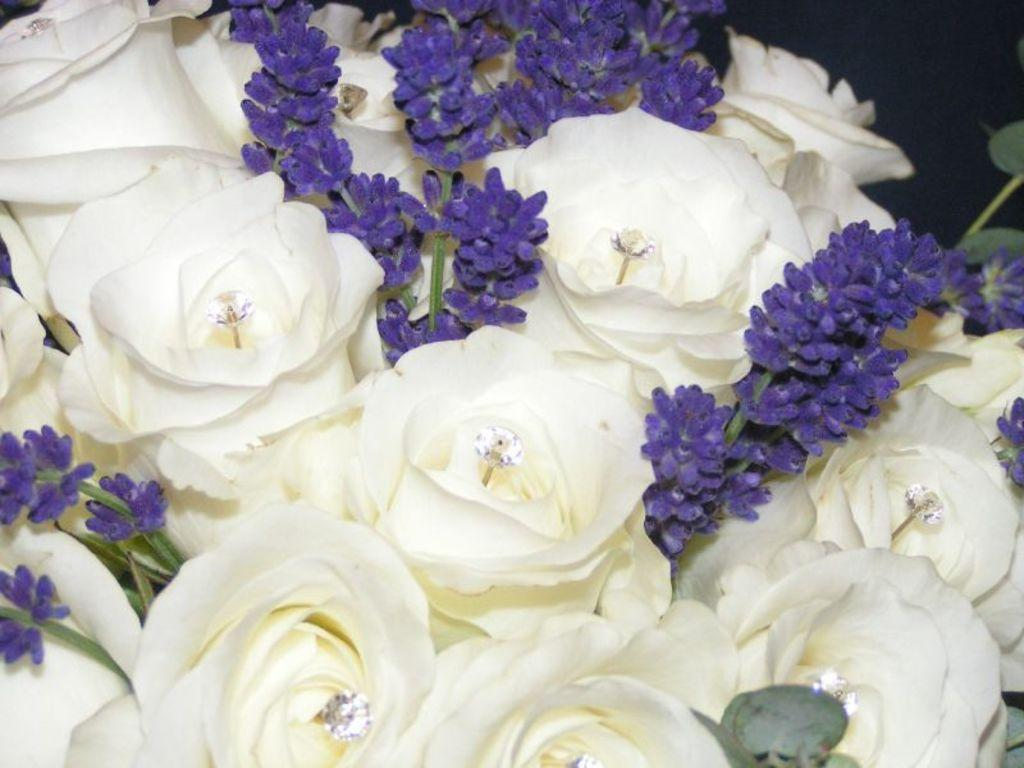What is the main subject of the image? The main subject of the image is flowers. Can you describe the flowers in the image? The flowers are located in the center of the image. What type of amusement can be seen in the image? There is no amusement present in the image; it features flowers in the center. Is there any poison visible in the image? There is no poison present in the image; it features flowers in the center. 